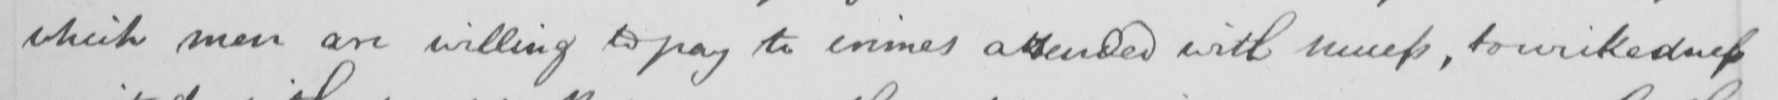Please provide the text content of this handwritten line. which men are willing to pay to crimes attended with success , to wickedness 